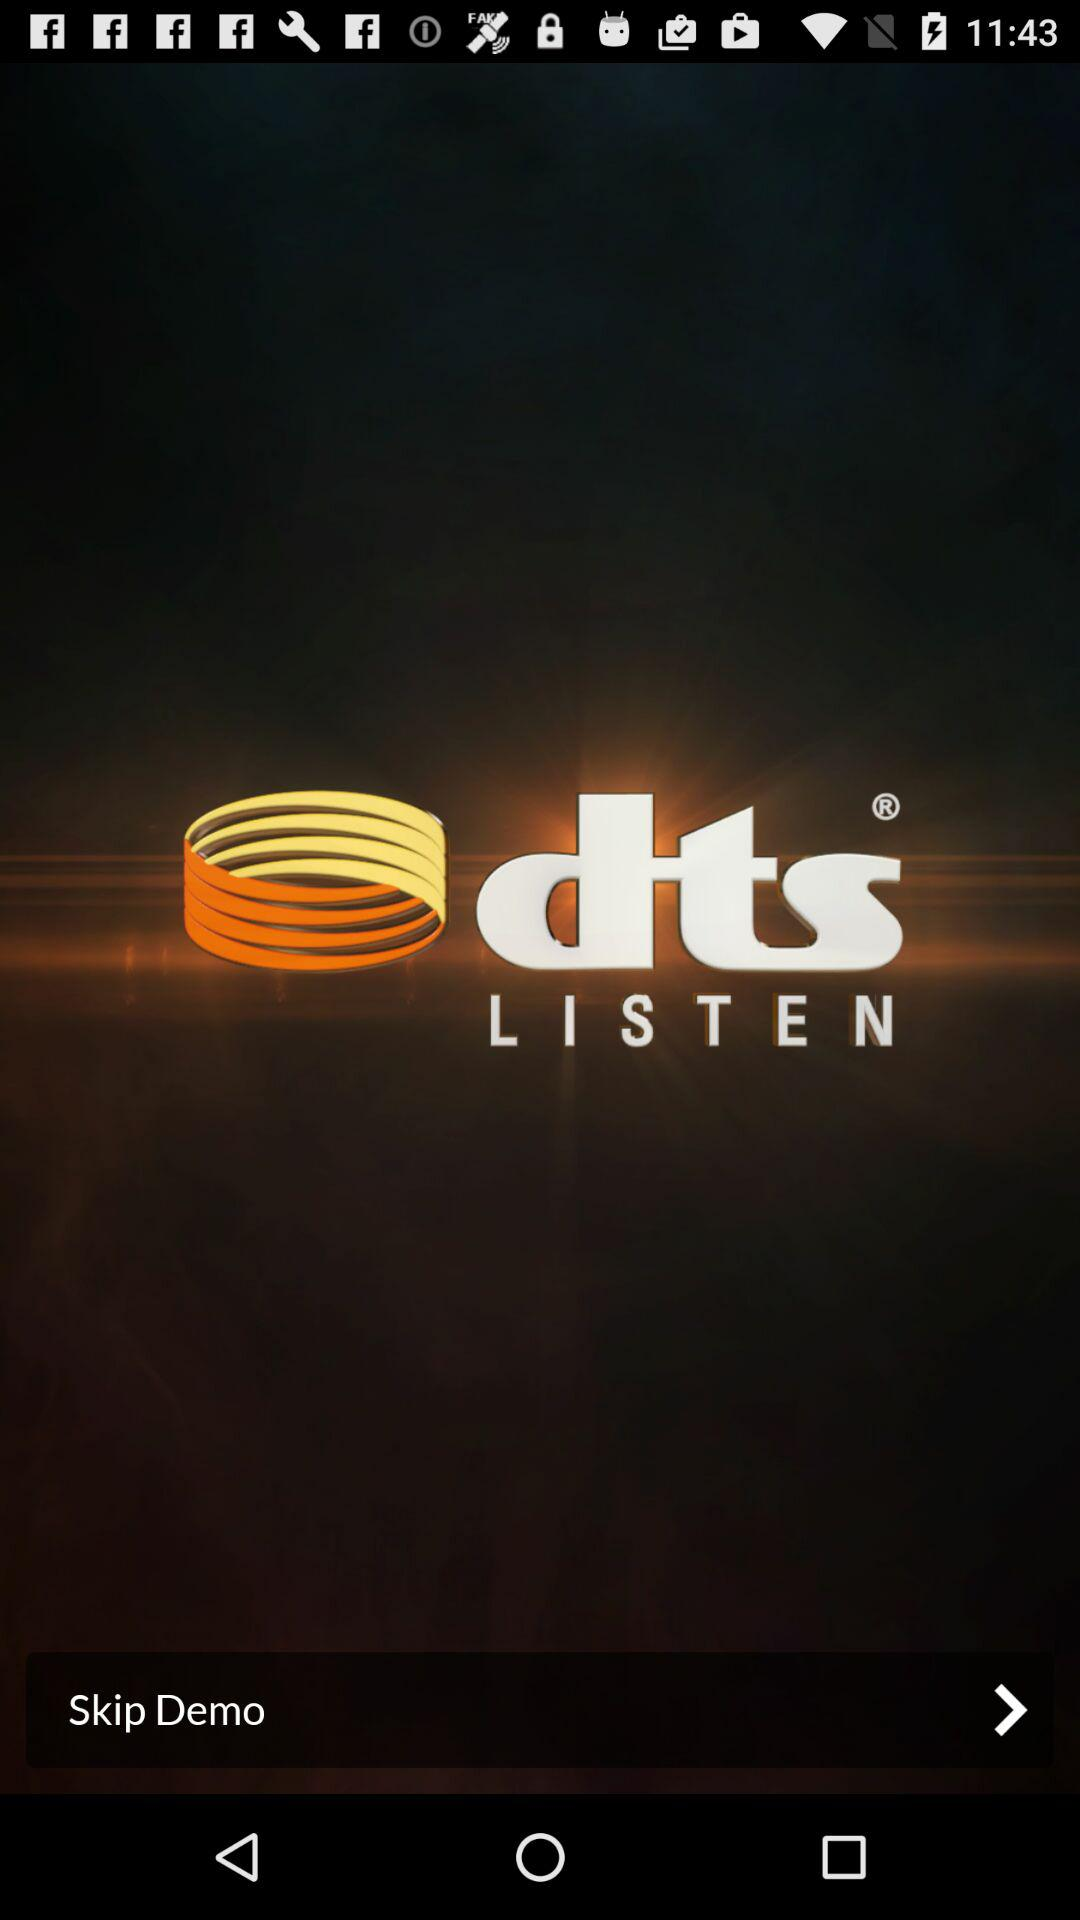What is the application name? The application name is "dts LISTEN". 